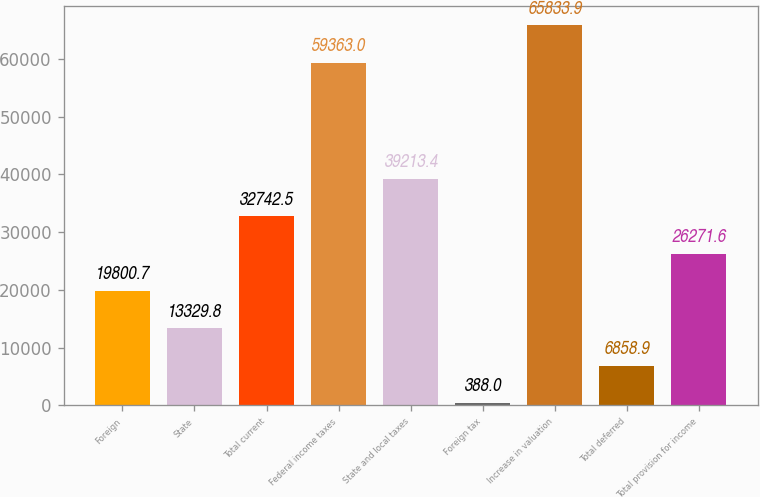Convert chart to OTSL. <chart><loc_0><loc_0><loc_500><loc_500><bar_chart><fcel>Foreign<fcel>State<fcel>Total current<fcel>Federal income taxes<fcel>State and local taxes<fcel>Foreign tax<fcel>Increase in valuation<fcel>Total deferred<fcel>Total provision for income<nl><fcel>19800.7<fcel>13329.8<fcel>32742.5<fcel>59363<fcel>39213.4<fcel>388<fcel>65833.9<fcel>6858.9<fcel>26271.6<nl></chart> 